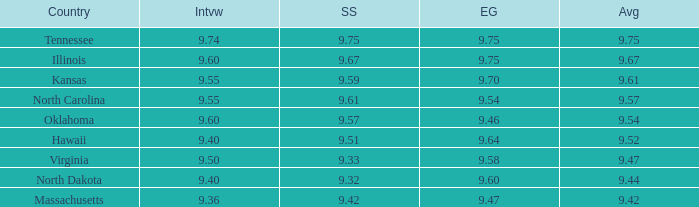What is the swimsuit score when the interview was 9.74? 9.75. 